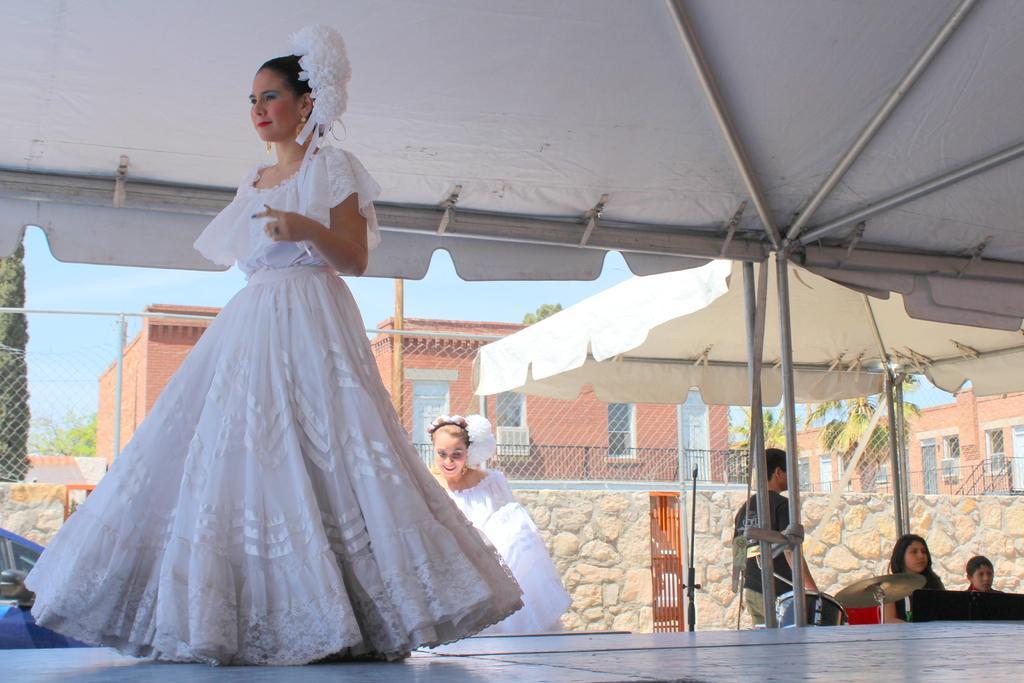Could you give a brief overview of what you see in this image? In this image I can see the person is wearing the white color dress and the person is standing under the tent. In the background I can see another person with white color dresses. To the side I can see the musical instruments in-front of few people. In the background I can see the wall and the railing. I can also see the buildings, trees and the sky. 